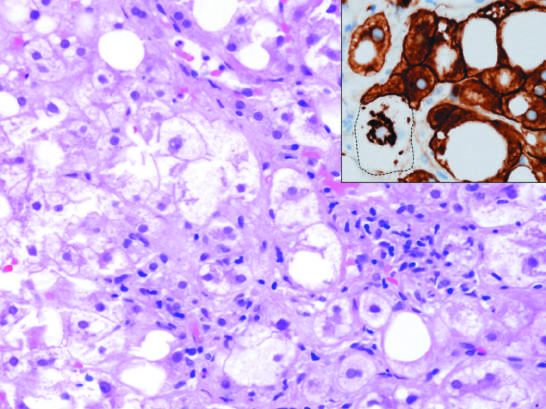s hepatocyte injury in fatty liver disease associated with chronic alcohol use?
Answer the question using a single word or phrase. Yes 